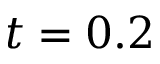Convert formula to latex. <formula><loc_0><loc_0><loc_500><loc_500>t = 0 . 2</formula> 